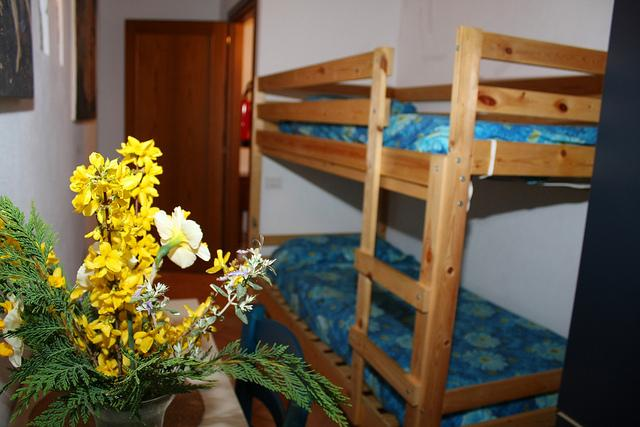What type of bed is shown? bunk 